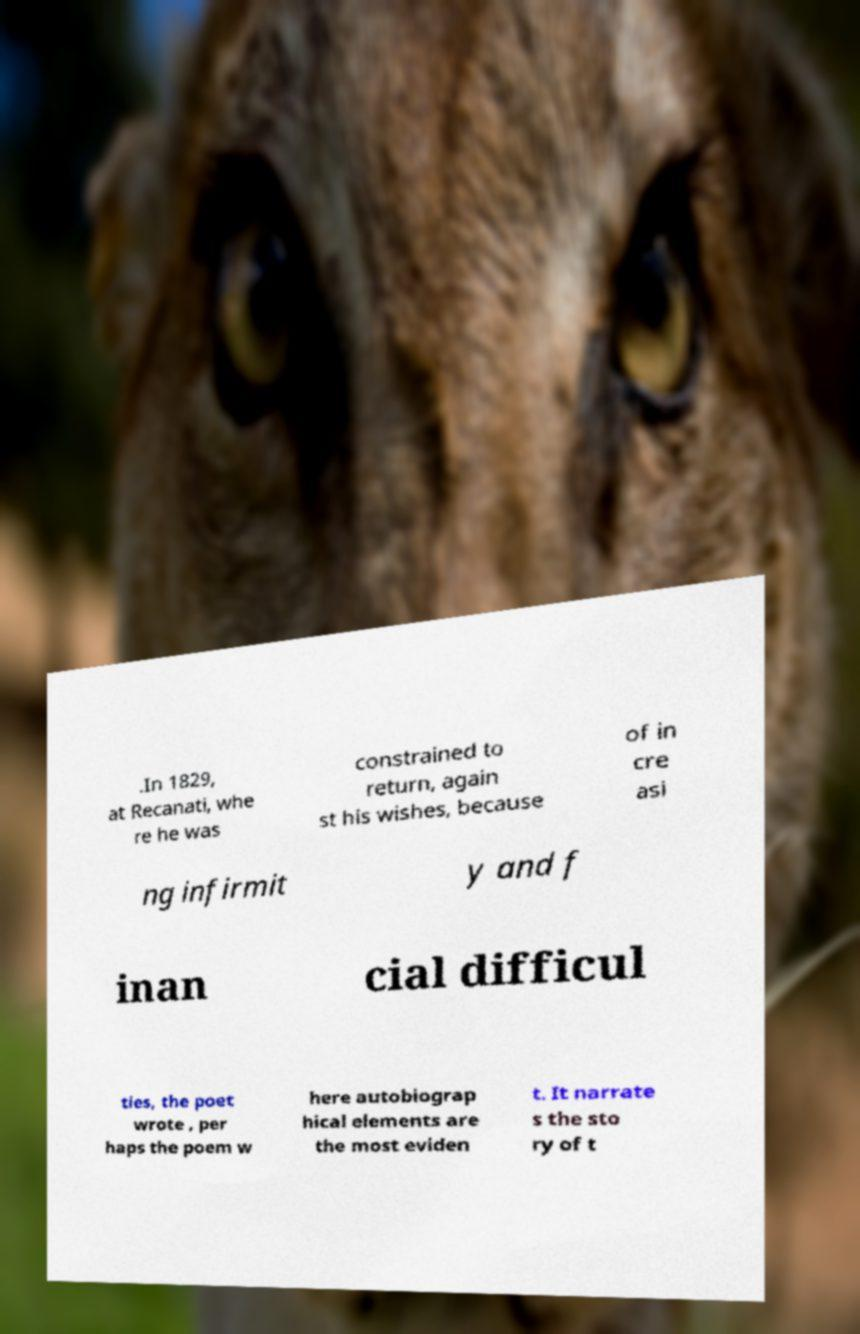For documentation purposes, I need the text within this image transcribed. Could you provide that? .In 1829, at Recanati, whe re he was constrained to return, again st his wishes, because of in cre asi ng infirmit y and f inan cial difficul ties, the poet wrote , per haps the poem w here autobiograp hical elements are the most eviden t. It narrate s the sto ry of t 